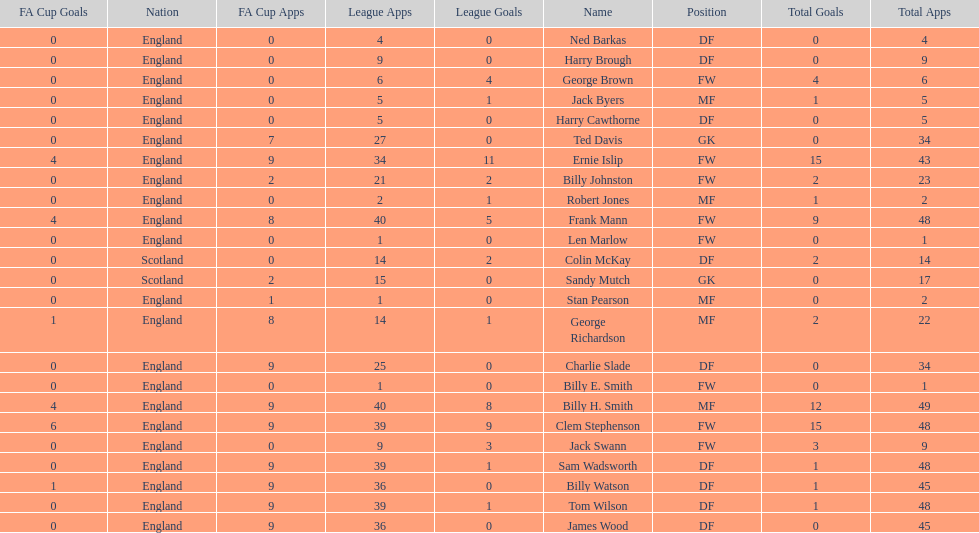What is the last name listed on this chart? James Wood. 